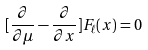Convert formula to latex. <formula><loc_0><loc_0><loc_500><loc_500>[ \frac { \partial } { \partial \mu } - \frac { \partial } { \partial x } ] F _ { \ell } ( x ) = 0</formula> 